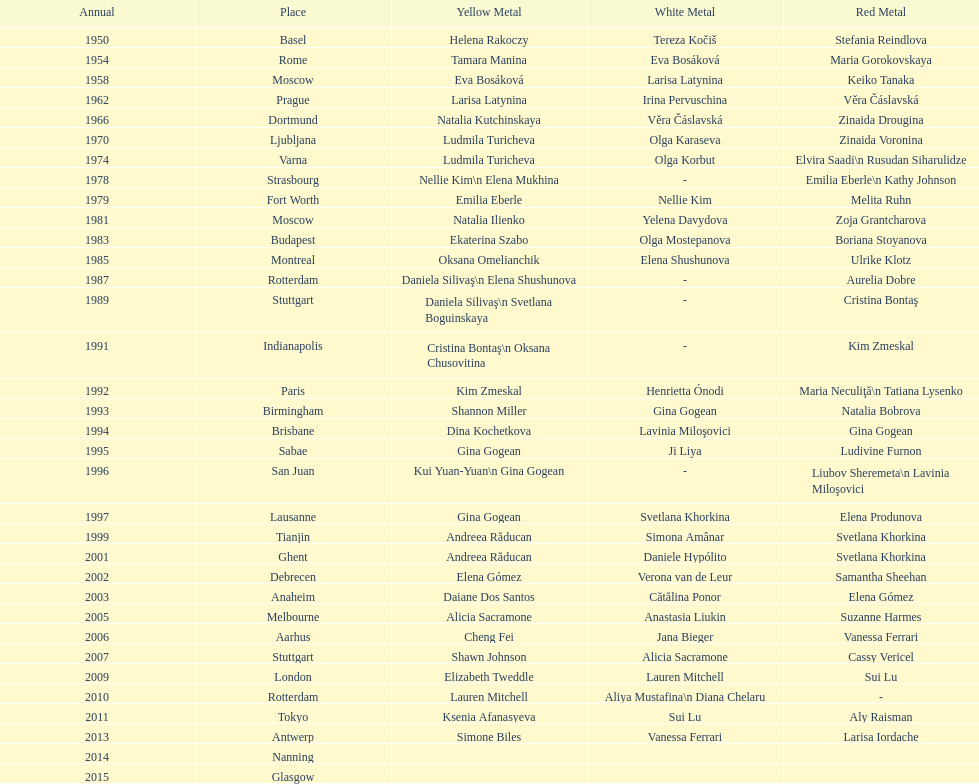How many times was the world artistic gymnastics championships held in the united states? 3. 